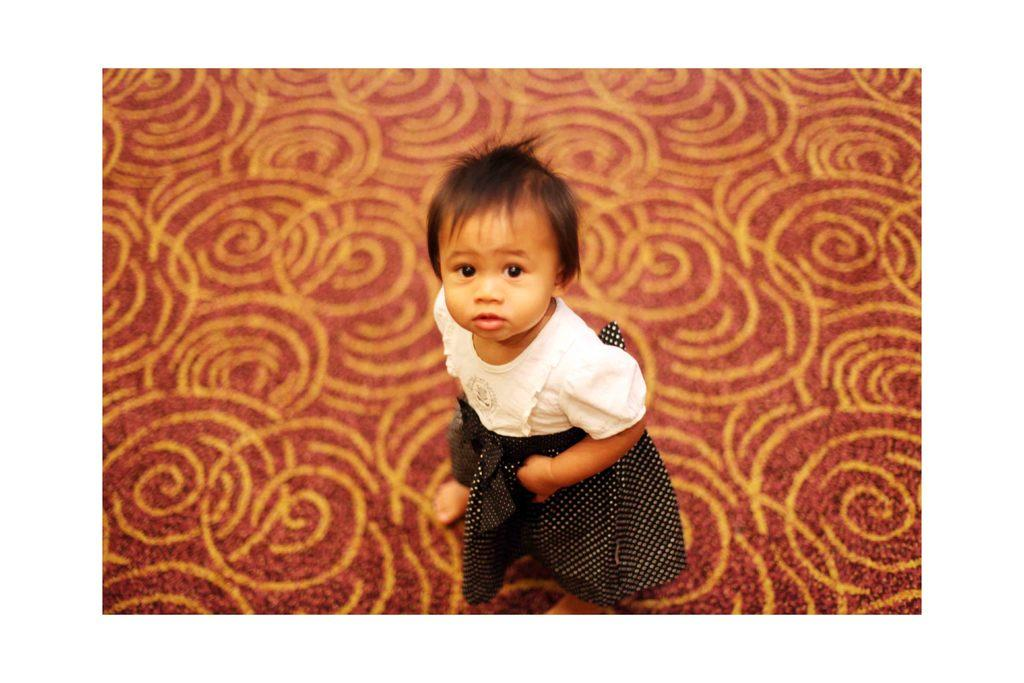What is the main subject of the image? There is a kid standing in the image. What can be seen beneath the kid's feet? The ground is visible in the image. What type of hill can be seen in the background of the image? There is no hill visible in the image; it only shows a kid standing on the ground. 